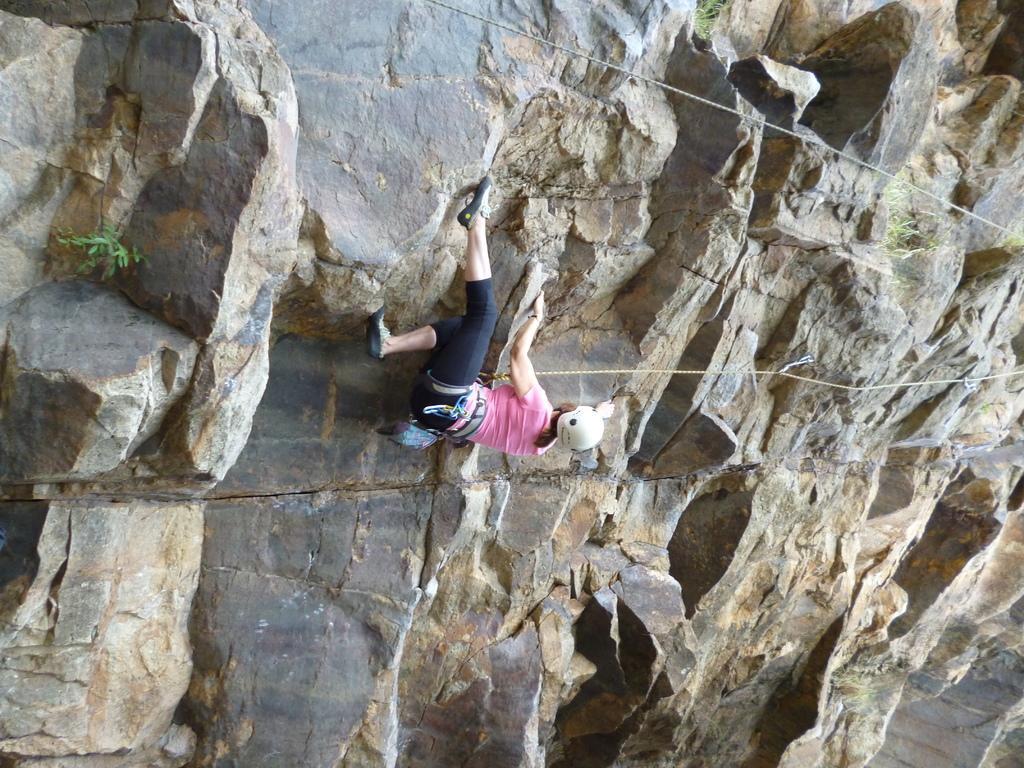Could you give a brief overview of what you see in this image? In the image in the center we can see one woman climbing hill,with the help of a rope. And she is wearing helmet. In the background we can see hill. 